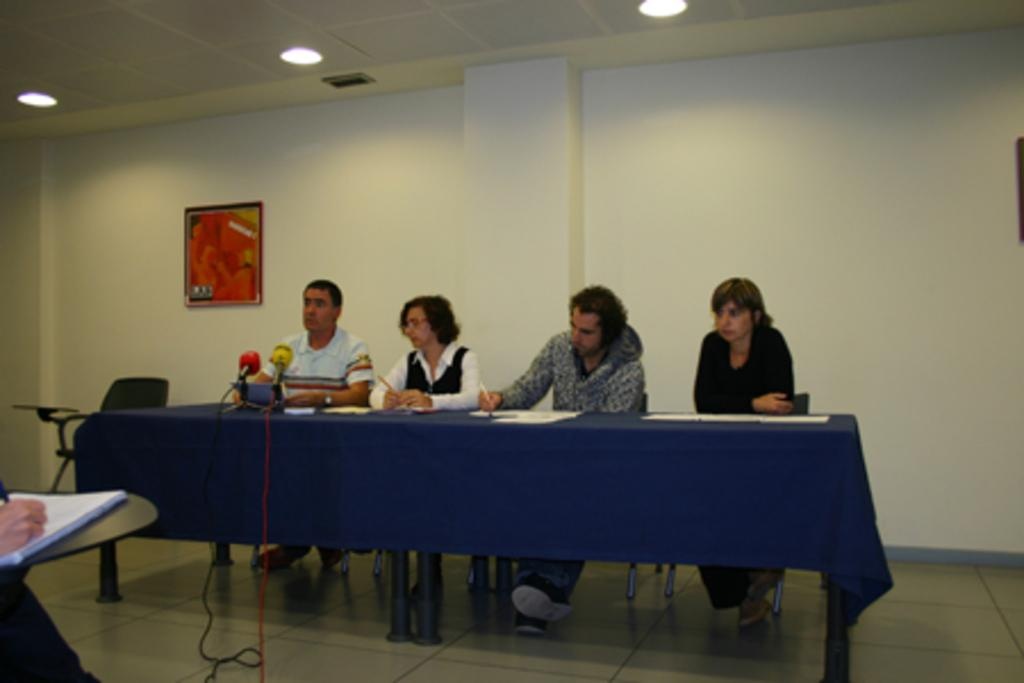What are the people in the image doing? The people in the image are sitting on chairs. What objects can be seen on the table in the image? There are mics on the table in the image. What is visible on the wall in the background of the image? There is a frame on the wall in the background of the image. What is located next to the frame in the background of the image? There is a chair next to the frame in the background of the image. What type of hen can be seen in the image? There is no hen present in the image. How does the image change when viewed in summer? The image does not change when viewed in summer, as it is a static image. 